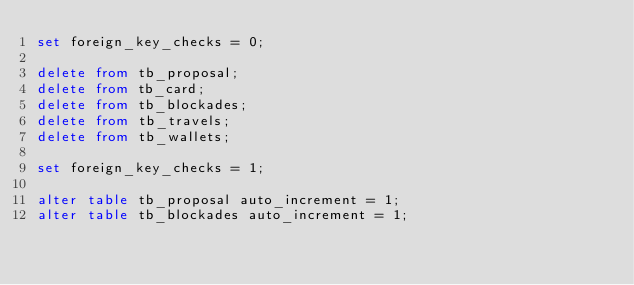Convert code to text. <code><loc_0><loc_0><loc_500><loc_500><_SQL_>set foreign_key_checks = 0;

delete from tb_proposal;
delete from tb_card;
delete from tb_blockades;
delete from tb_travels;
delete from tb_wallets;

set foreign_key_checks = 1;

alter table tb_proposal auto_increment = 1;
alter table tb_blockades auto_increment = 1;</code> 